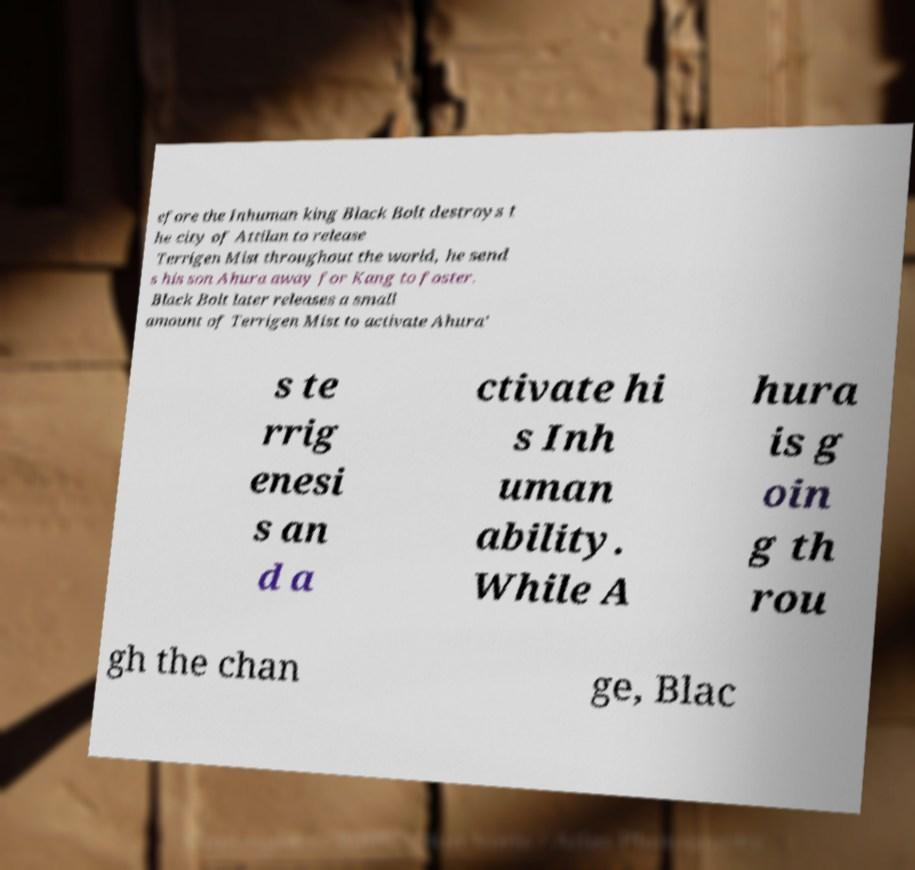I need the written content from this picture converted into text. Can you do that? efore the Inhuman king Black Bolt destroys t he city of Attilan to release Terrigen Mist throughout the world, he send s his son Ahura away for Kang to foster. Black Bolt later releases a small amount of Terrigen Mist to activate Ahura' s te rrig enesi s an d a ctivate hi s Inh uman ability. While A hura is g oin g th rou gh the chan ge, Blac 